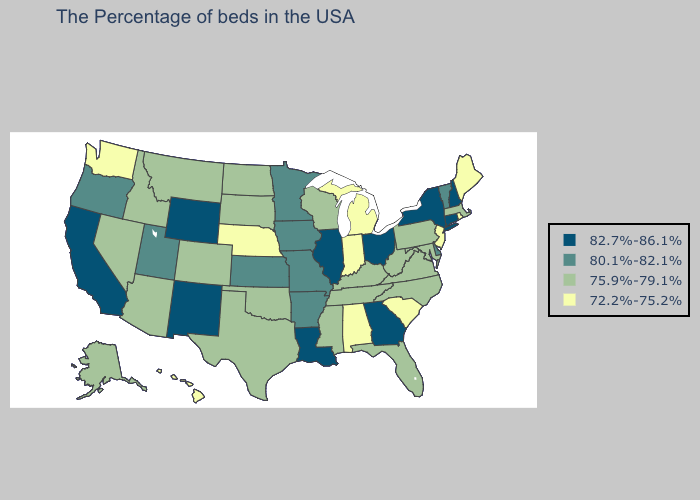What is the lowest value in the USA?
Give a very brief answer. 72.2%-75.2%. Name the states that have a value in the range 82.7%-86.1%?
Give a very brief answer. New Hampshire, Connecticut, New York, Ohio, Georgia, Illinois, Louisiana, Wyoming, New Mexico, California. Does the map have missing data?
Short answer required. No. Does the first symbol in the legend represent the smallest category?
Short answer required. No. Does Hawaii have the highest value in the USA?
Be succinct. No. What is the lowest value in the Northeast?
Give a very brief answer. 72.2%-75.2%. Does Pennsylvania have the highest value in the Northeast?
Write a very short answer. No. Does New Mexico have the highest value in the USA?
Concise answer only. Yes. Does New Mexico have the highest value in the West?
Write a very short answer. Yes. Name the states that have a value in the range 72.2%-75.2%?
Give a very brief answer. Maine, Rhode Island, New Jersey, South Carolina, Michigan, Indiana, Alabama, Nebraska, Washington, Hawaii. Does Washington have the highest value in the West?
Concise answer only. No. What is the value of Rhode Island?
Answer briefly. 72.2%-75.2%. Name the states that have a value in the range 82.7%-86.1%?
Concise answer only. New Hampshire, Connecticut, New York, Ohio, Georgia, Illinois, Louisiana, Wyoming, New Mexico, California. What is the lowest value in the South?
Write a very short answer. 72.2%-75.2%. Name the states that have a value in the range 80.1%-82.1%?
Give a very brief answer. Vermont, Delaware, Missouri, Arkansas, Minnesota, Iowa, Kansas, Utah, Oregon. 